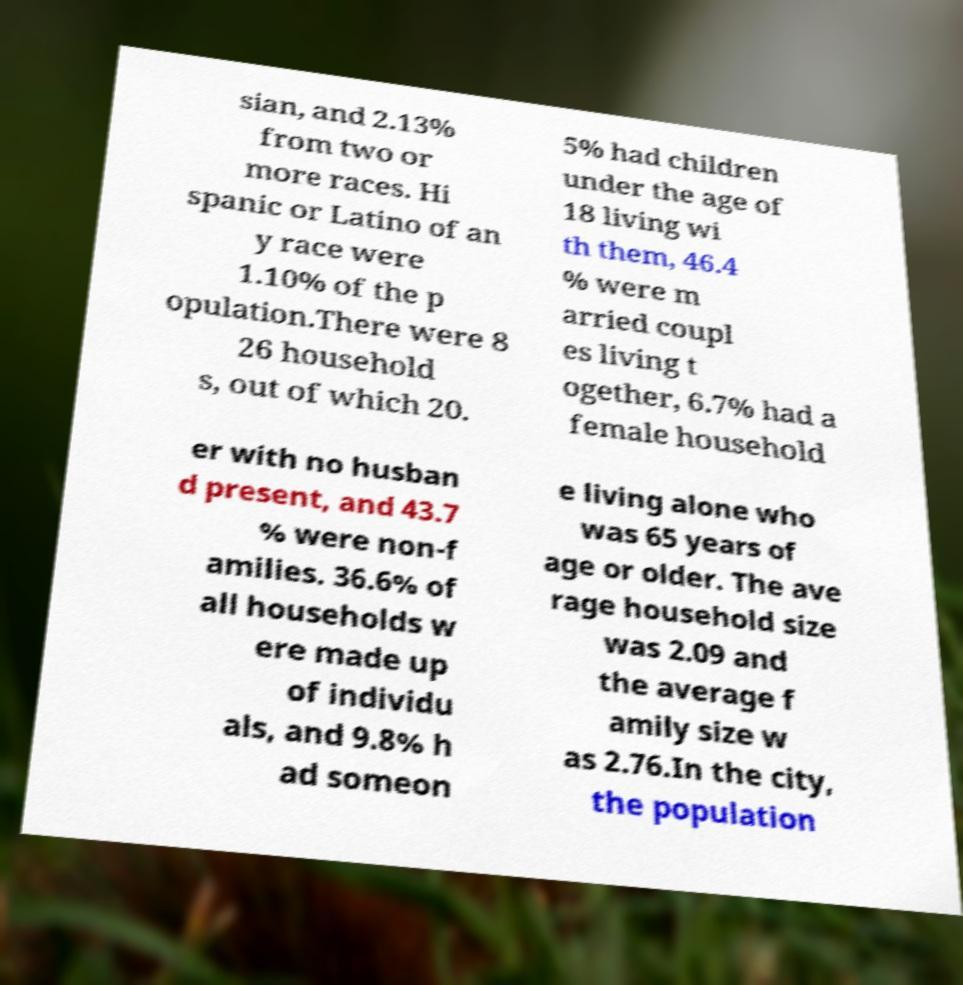Can you read and provide the text displayed in the image?This photo seems to have some interesting text. Can you extract and type it out for me? sian, and 2.13% from two or more races. Hi spanic or Latino of an y race were 1.10% of the p opulation.There were 8 26 household s, out of which 20. 5% had children under the age of 18 living wi th them, 46.4 % were m arried coupl es living t ogether, 6.7% had a female household er with no husban d present, and 43.7 % were non-f amilies. 36.6% of all households w ere made up of individu als, and 9.8% h ad someon e living alone who was 65 years of age or older. The ave rage household size was 2.09 and the average f amily size w as 2.76.In the city, the population 